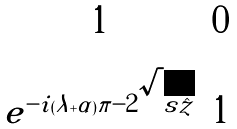Convert formula to latex. <formula><loc_0><loc_0><loc_500><loc_500>\begin{matrix} 1 & 0 \\ e ^ { - i ( \lambda + \alpha ) \pi - 2 \sqrt { s \hat { z } } } & 1 \\ \end{matrix}</formula> 